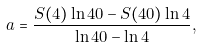Convert formula to latex. <formula><loc_0><loc_0><loc_500><loc_500>a = \frac { S ( 4 ) \ln 4 0 - S ( 4 0 ) \ln 4 } { \ln 4 0 - \ln 4 } ,</formula> 